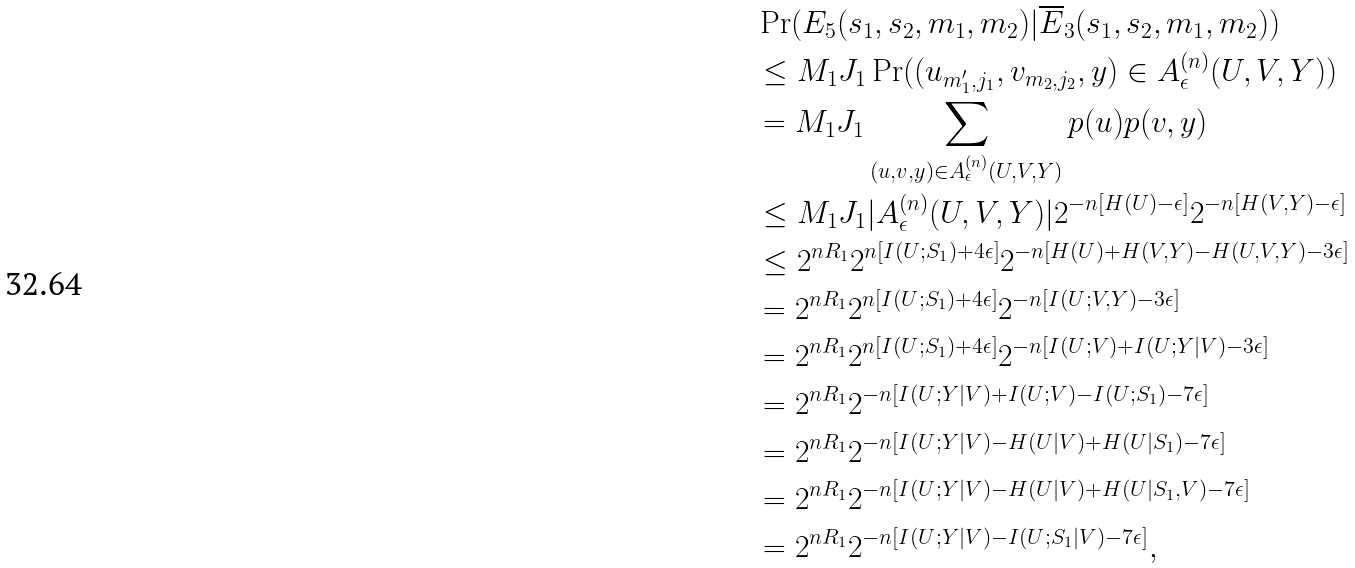Convert formula to latex. <formula><loc_0><loc_0><loc_500><loc_500>& \Pr ( E _ { 5 } ( s _ { 1 } , s _ { 2 } , m _ { 1 } , m _ { 2 } ) | \overline { E } _ { 3 } ( s _ { 1 } , s _ { 2 } , m _ { 1 } , m _ { 2 } ) ) \\ & \leq M _ { 1 } J _ { 1 } \Pr ( ( u _ { m ^ { \prime } _ { 1 } , j _ { 1 } } , v _ { m _ { 2 } , j _ { 2 } } , y ) \in A _ { \epsilon } ^ { ( n ) } ( U , V , Y ) ) \\ & = M _ { 1 } J _ { 1 } \sum _ { ( u , v , y ) \in A _ { \epsilon } ^ { ( n ) } ( U , V , Y ) } p ( u ) p ( v , y ) \\ & \leq M _ { 1 } J _ { 1 } | A _ { \epsilon } ^ { ( n ) } ( U , V , Y ) | 2 ^ { - n [ H ( U ) - \epsilon ] } 2 ^ { - n [ H ( V , Y ) - \epsilon ] } \\ & \leq 2 ^ { n R _ { 1 } } 2 ^ { n [ I ( U ; S _ { 1 } ) + 4 \epsilon ] } 2 ^ { - n [ H ( U ) + H ( V , Y ) - H ( U , V , Y ) - 3 \epsilon ] } \\ & = 2 ^ { n R _ { 1 } } 2 ^ { n [ I ( U ; S _ { 1 } ) + 4 \epsilon ] } 2 ^ { - n [ I ( U ; V , Y ) - 3 \epsilon ] } \\ & = 2 ^ { n R _ { 1 } } 2 ^ { n [ I ( U ; S _ { 1 } ) + 4 \epsilon ] } 2 ^ { - n [ I ( U ; V ) + I ( U ; Y | V ) - 3 \epsilon ] } \\ & = 2 ^ { n R _ { 1 } } 2 ^ { - n [ I ( U ; Y | V ) + I ( U ; V ) - I ( U ; S _ { 1 } ) - 7 \epsilon ] } \\ & = 2 ^ { n R _ { 1 } } 2 ^ { - n [ I ( U ; Y | V ) - H ( U | V ) + H ( U | S _ { 1 } ) - 7 \epsilon ] } \\ & = 2 ^ { n R _ { 1 } } 2 ^ { - n [ I ( U ; Y | V ) - H ( U | V ) + H ( U | S _ { 1 } , V ) - 7 \epsilon ] } \\ & = 2 ^ { n R _ { 1 } } 2 ^ { - n [ I ( U ; Y | V ) - I ( U ; S _ { 1 } | V ) - 7 \epsilon ] } ,</formula> 